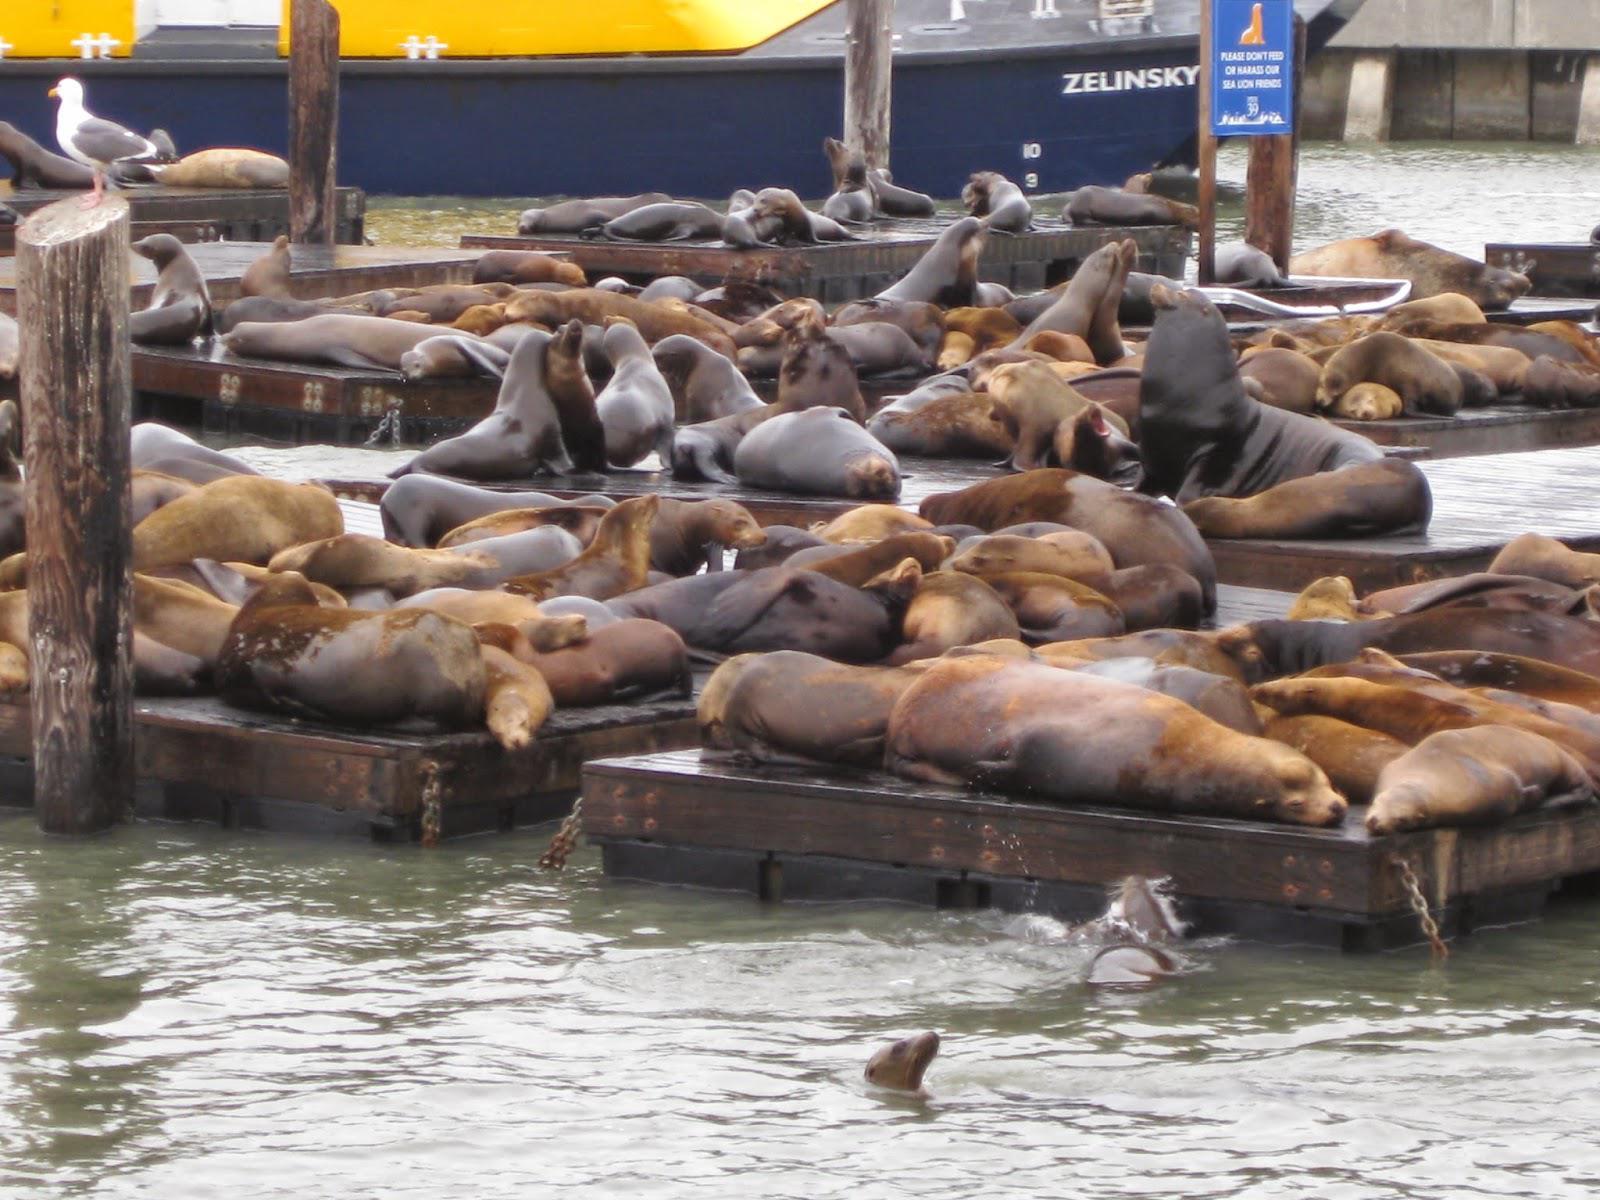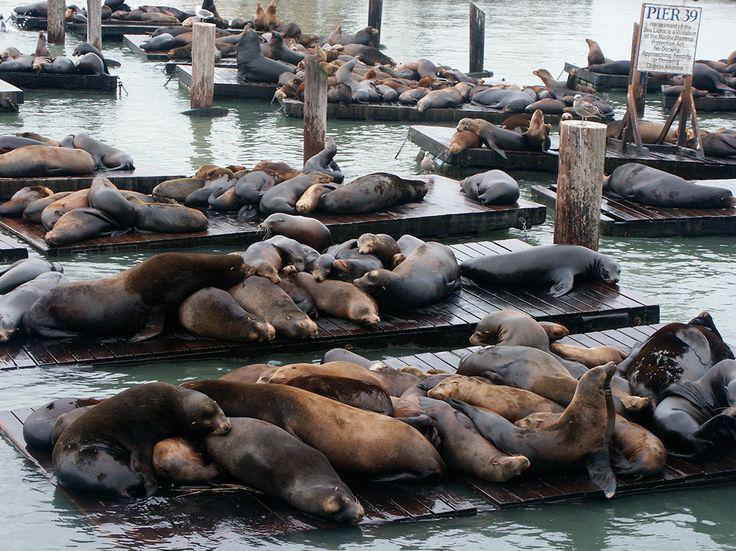The first image is the image on the left, the second image is the image on the right. Examine the images to the left and right. Is the description "A seal's head shows above the water in front of a floating platform packed with seals, in the left image." accurate? Answer yes or no. Yes. The first image is the image on the left, the second image is the image on the right. For the images displayed, is the sentence "There are at most two sea lions swimming in water." factually correct? Answer yes or no. Yes. 